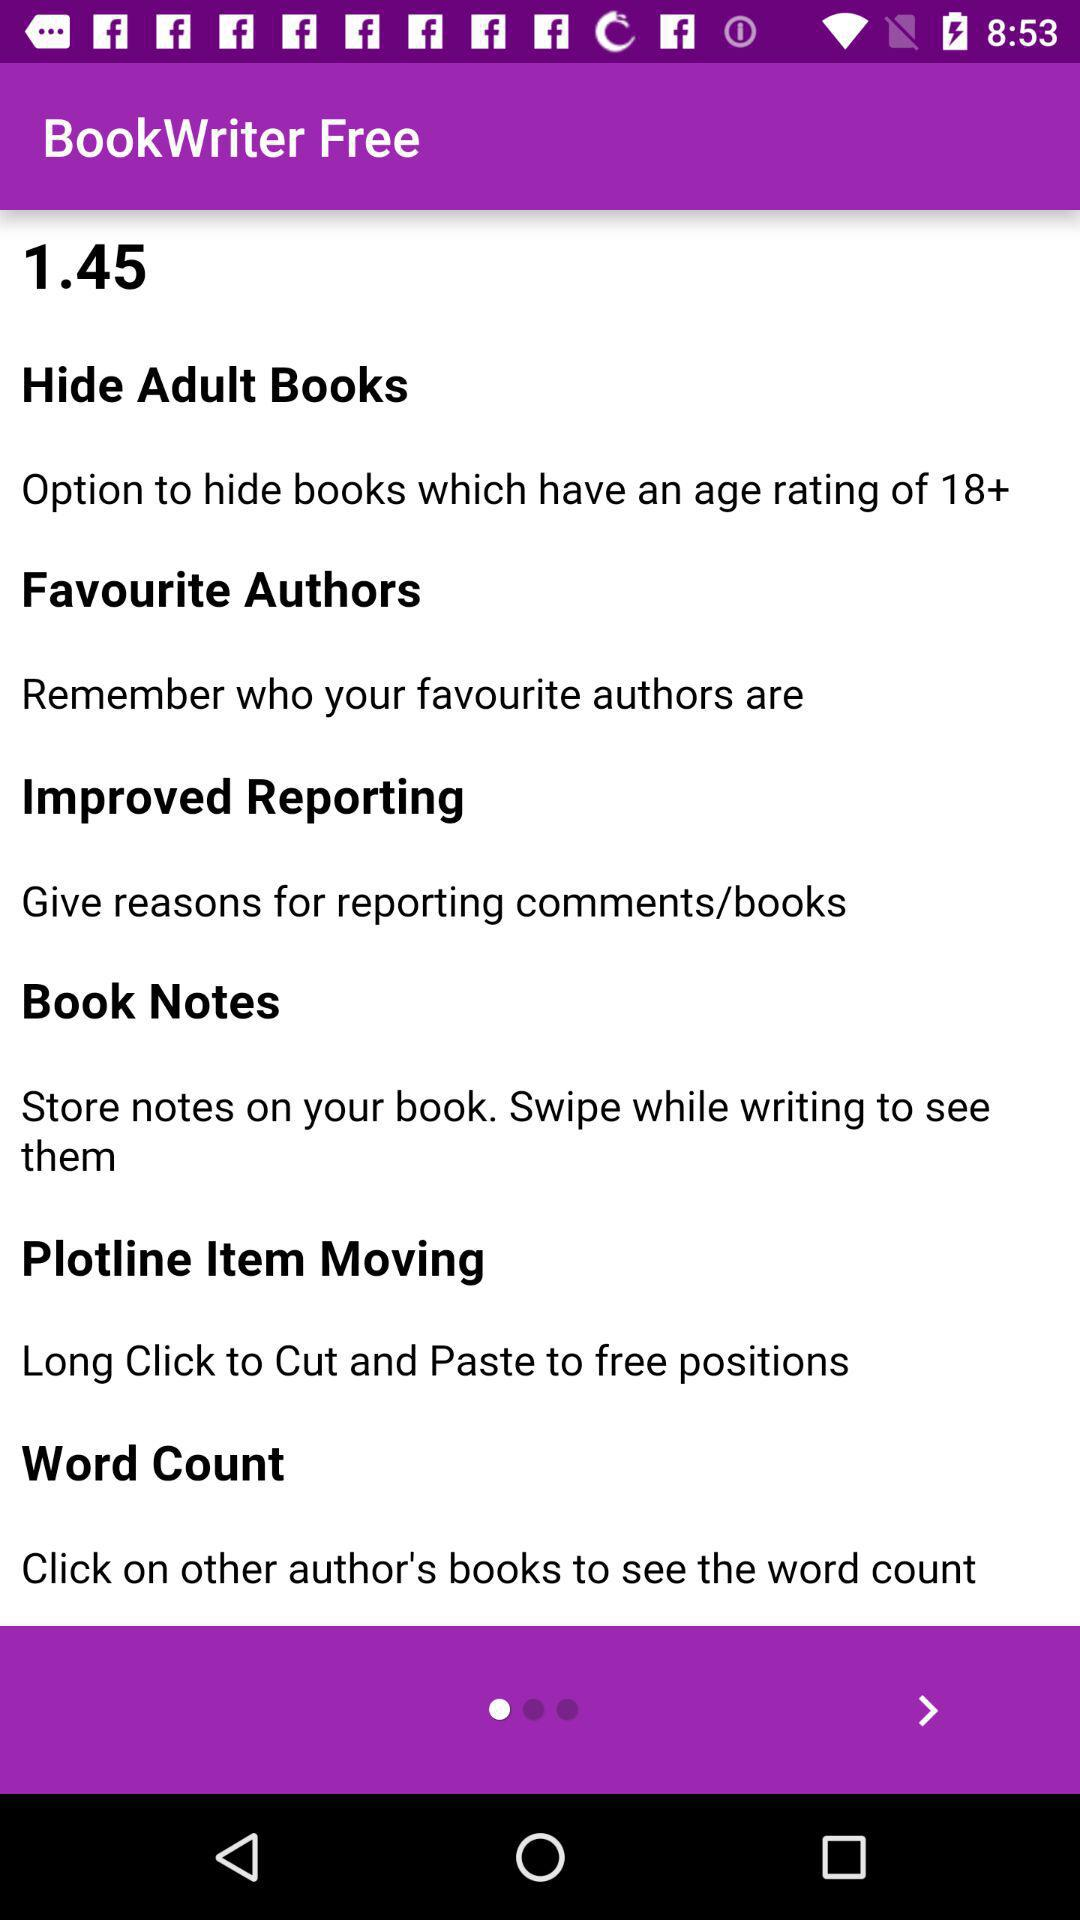What is the name of the application? The name of the application is "BookWriter Free". 